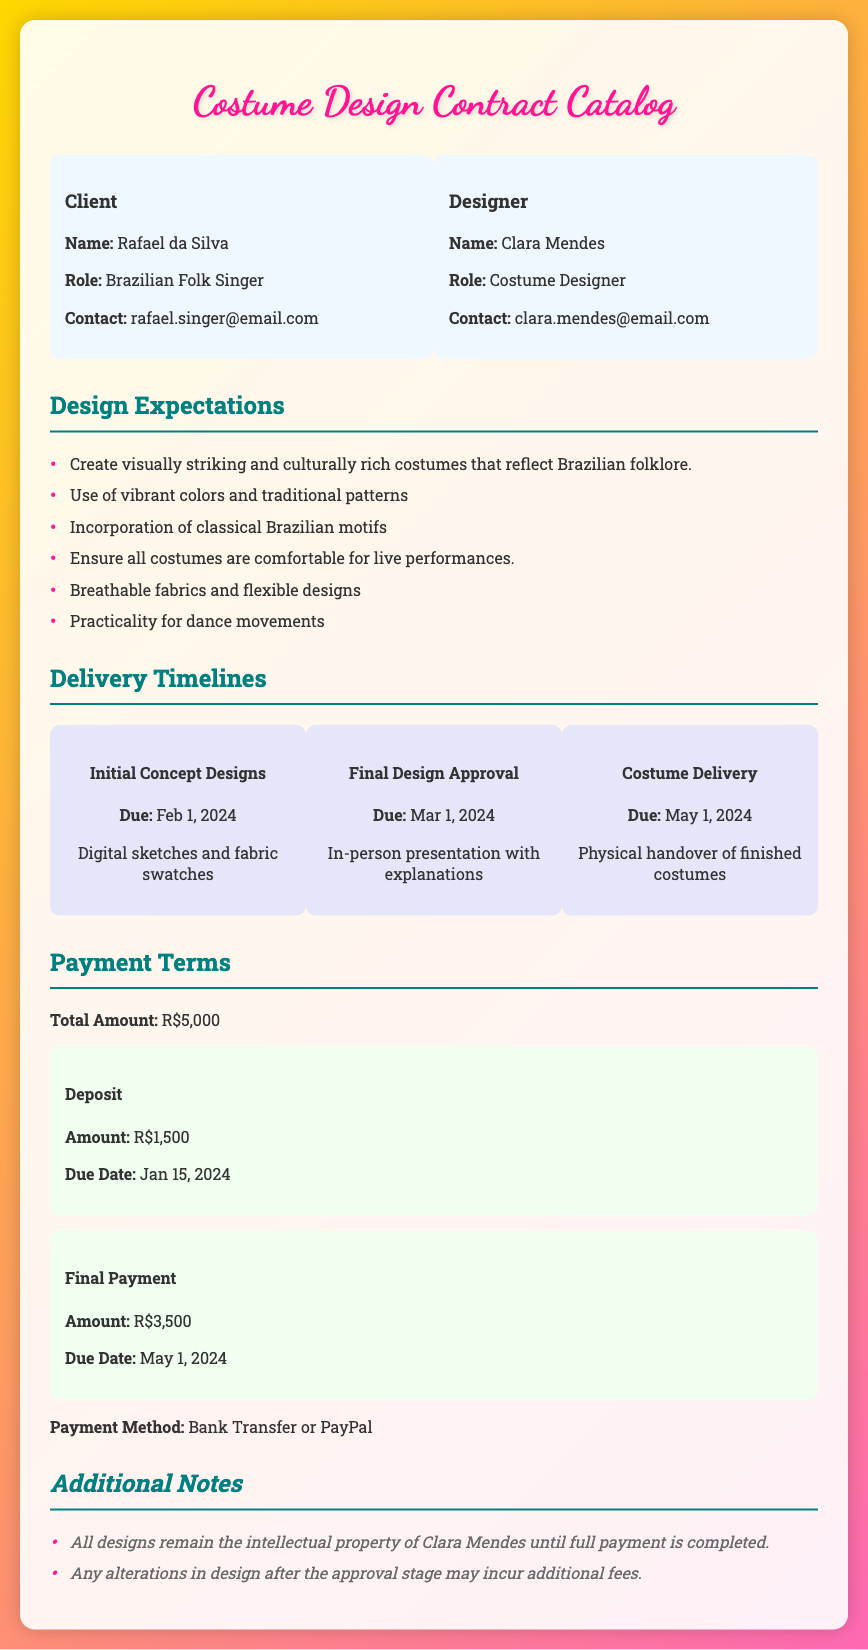what is the client's name? The client's name is explicitly mentioned in the document under the "Client" section.
Answer: Rafael da Silva what is the designer's role? The role of the designer is stated in the "Designer" section of the document.
Answer: Costume Designer what is the due date for the Initial Concept Designs? The due date for this milestone is specified under the "Delivery Timelines" section.
Answer: Feb 1, 2024 how much is the total payment? The total payment amount is clearly stated under the "Payment Terms" section of the document.
Answer: R$5,000 what is the amount of the deposit? The deposit amount is outlined in the "Payment Terms" section.
Answer: R$1,500 what are the due dates for payments? The document lists two payment due dates, one for the deposit and one for the final payment.
Answer: Jan 15, 2024; May 1, 2024 what is required from the designer in terms of costume design? The key expectations from the designer are outlined in the "Design Expectations" section.
Answer: Visually striking and culturally rich costumes how will the finalized designs be presented? The method of presentation is mentioned in the "Delivery Timelines" for the final design approval.
Answer: In-person presentation with explanations what happens to the design intellectual property before payment? The conditions related to intellectual property are indicated under the "Additional Notes".
Answer: Remain the intellectual property of Clara Mendes until full payment is completed 